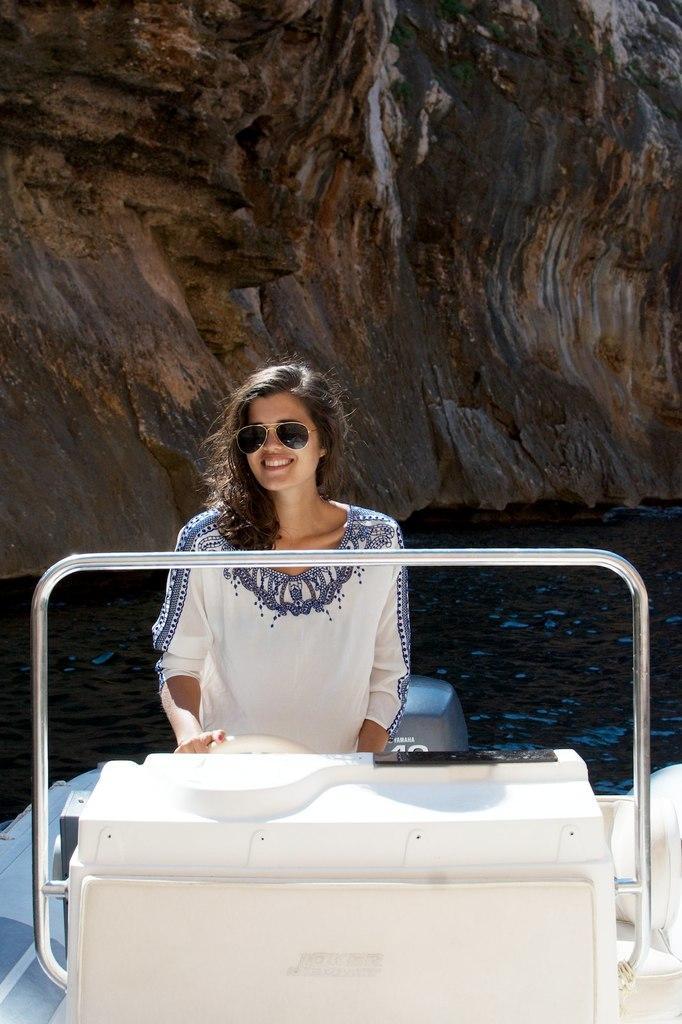Could you give a brief overview of what you see in this image? In this picture there is a woman standing on the boat and smiling and she is holding the steering. There is a boat on the water. At the back there is a hill. At the bottom there is water. 